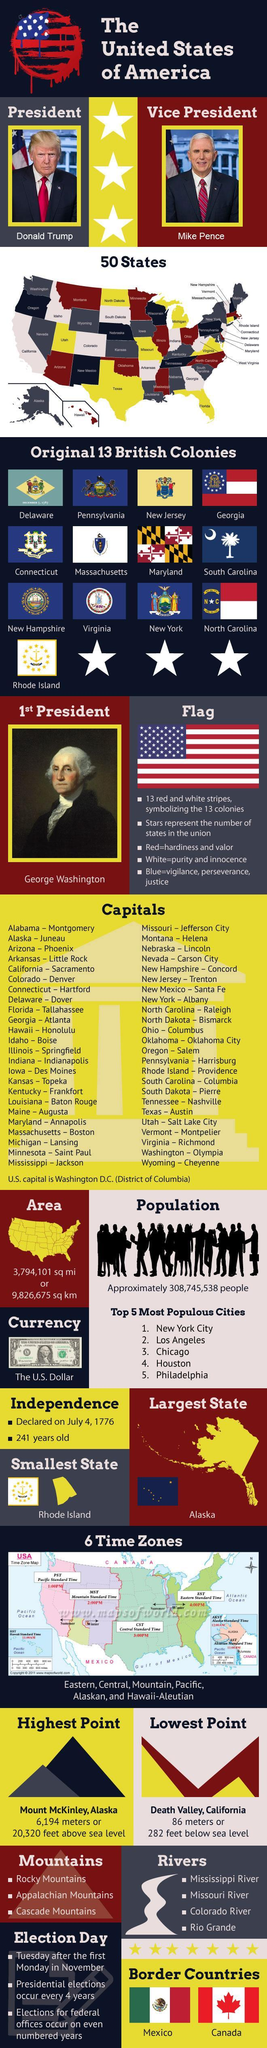Which is the largest state in America?
Answer the question with a short phrase. Alaska What is the currency of America? The U.S. Dollar What is the height of the highest point of America? 6,194 meters or 20,320 feet above sea level What is the name of the Vice President? Mike Pence How many countries share their border with America? 2 How many states of America are shown in brown color in the map? 11 What is the depth of the lowest point in America? 282 feet below sea level what is the population of America? 308,745,538 people How much is the area of America in square miles? 3,794,101 sq mi What is the name of the western most island shown in the map? Alaska 